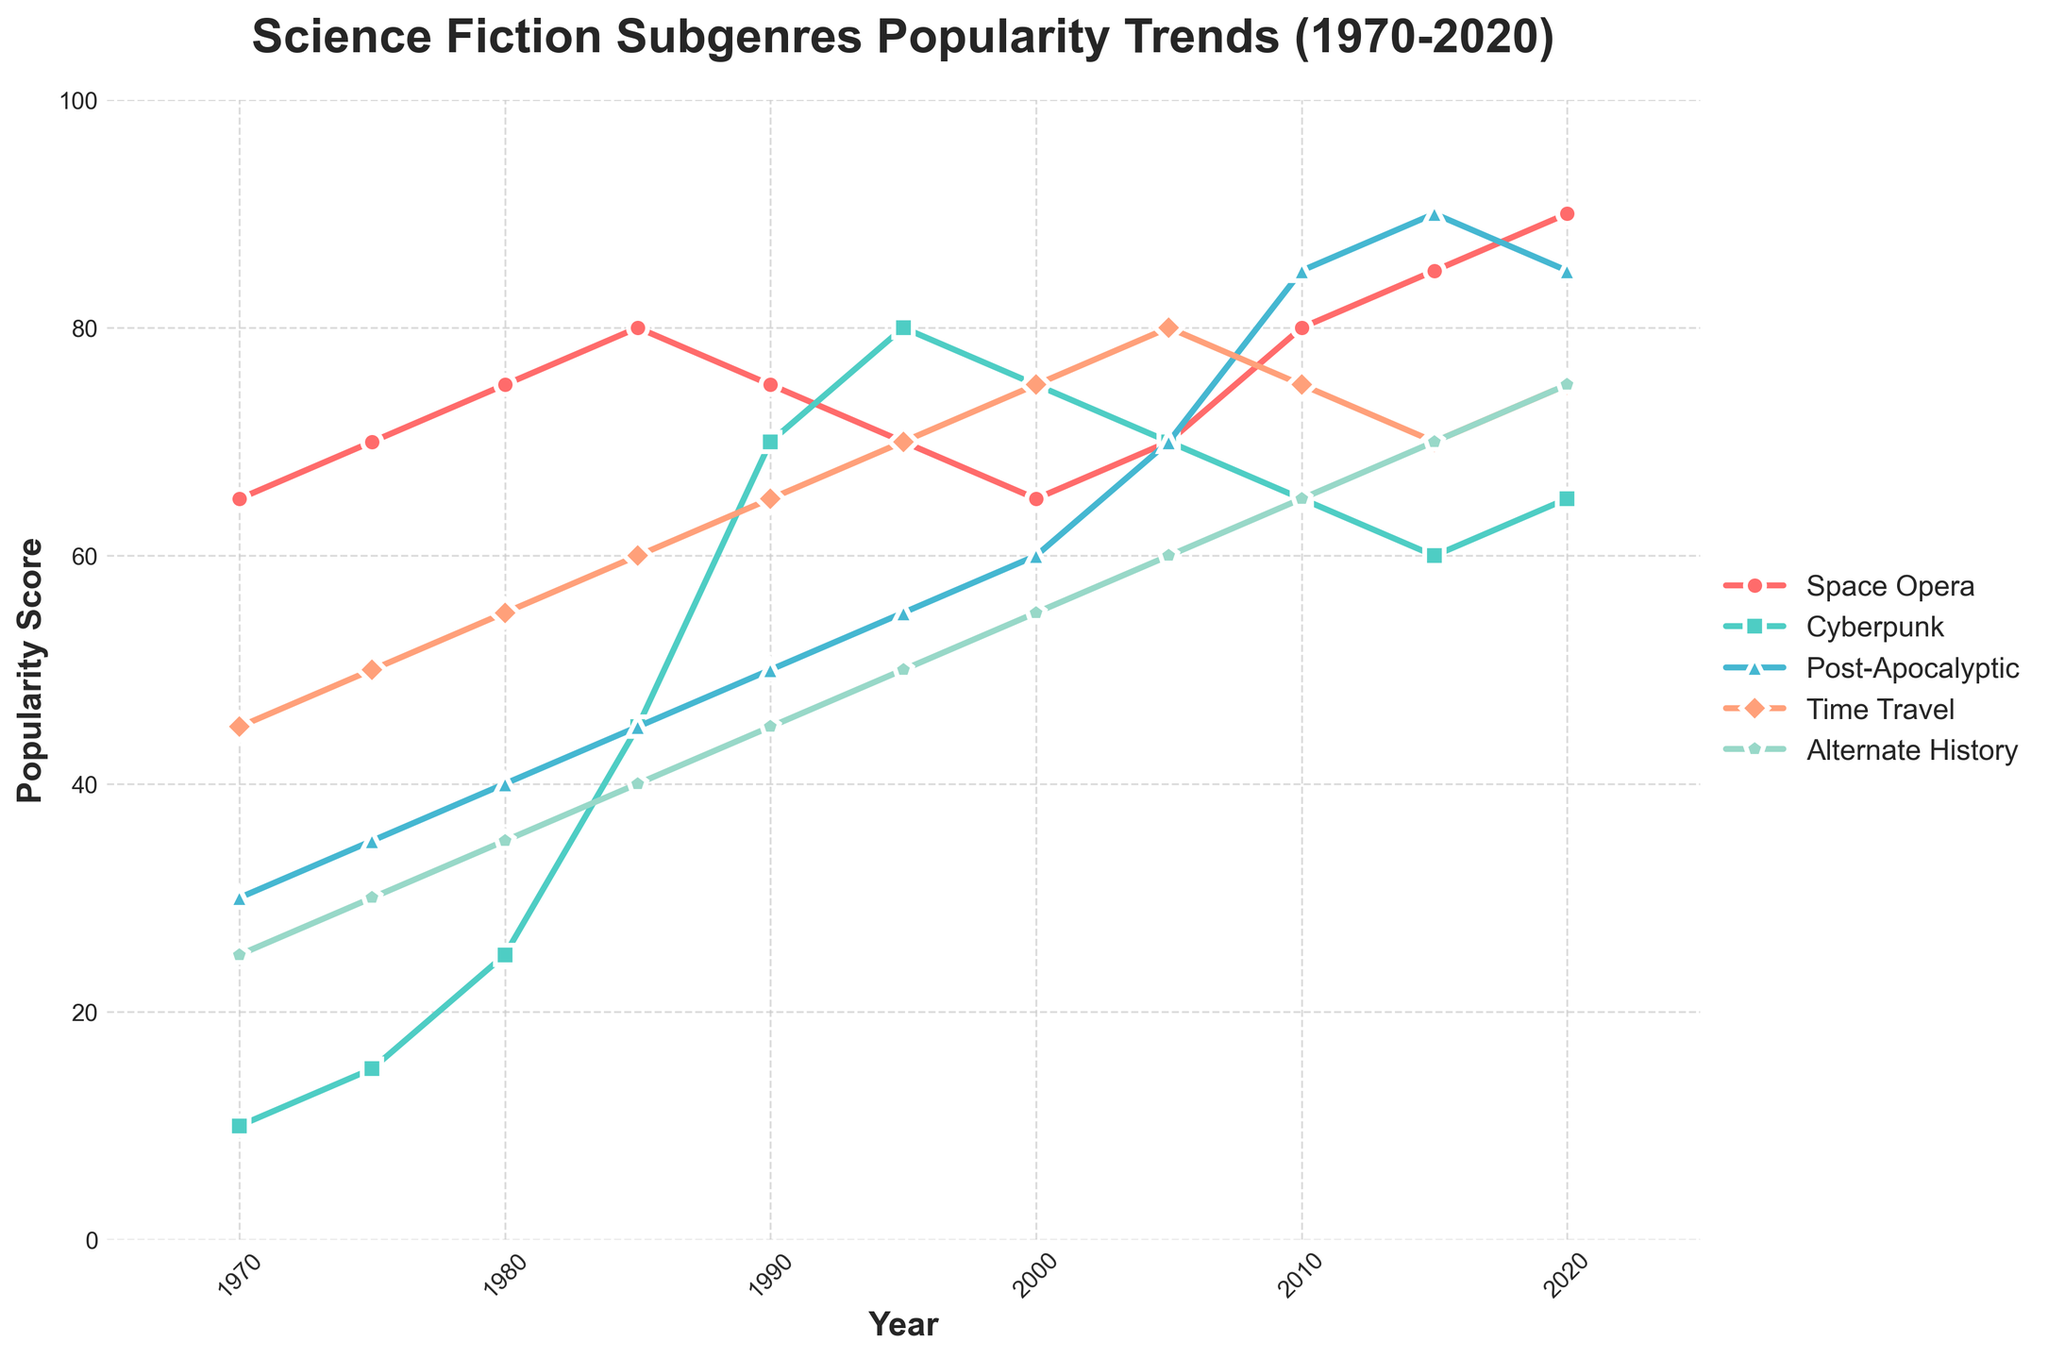What is the trend of the Space Opera subgenre from 1970 to 2020? The Space Opera subgenre starts at a popularity score of 65 in 1970 and shows an upward trend, reaching its peak at 90 in 2020.
Answer: Upward trend Which subgenre experienced the highest increase in popularity from 1970 to 2020? By examining the start and end values of each subgenre, the Post-Apocalyptic subgenre increased from 30 to 85, reflecting the highest increase of 55 points.
Answer: Post-Apocalyptic In which year did Cyberpunk reach its peak popularity? The Cyberpunk subgenre achieved its peak popularity in 1995 with a score of 80.
Answer: 1995 Between which years did the Time Travel subgenre see the steepest rise in popularity? The Time Travel subgenre saw multiple rises, but the steepest rise occurred between 1970 (popularity score of 45) and 2005 (popularity score of 80), a 35-point increase.
Answer: 1970-2005 How does the popularity of Alternate History in 2020 compare to its popularity in 1970? In 1970, Alternate History had a score of 25, which increased to 75 by 2020. This is a rise of 50 points over 50 years.
Answer: Higher in 2020 What is the average popularity score of Cyberpunk from 1970 to 2020? Sum the scores of Cyberpunk for each year (10 + 15 + 25 + 45 + 70 + 80 + 75 + 70 + 65 + 60 + 65 = 580) and divide by the number of years (11). The average score is 580 / 11 ≈ 52.7.
Answer: 52.7 Which subgenre had the least variation in popularity from 1970 to 2020? By visually examining the consistency in trends, Alternate History appears to have the least variation as it scales up at a steady pace compared to the others.
Answer: Alternate History What was the popularity score of Post-Apocalyptic subgenre in 2000, and how does it compare to its score in 2015? In 2000, the score was 60. In 2015, it was 90. The increase from 2000 to 2015 was 30 points.
Answer: Increased by 30 points Which subgenre showed a dip in popularity after reaching a peak, and in which years did this occur? Space Opera peaked in 1985 at 80 and then dipped to 75 in 1990, showing a decrease of 5 points.
Answer: Space Opera, 1985-1990 Arrange the subgenres in descending order of their popularity scores in 2020. The scores in 2020 are: Space Opera (90), Cyberpunk (65), Post-Apocalyptic (85), Time Travel (75), Alternate History (75). Thus, the order is: Space Opera, Post-Apocalyptic, Time Travel, Alternate History, Cyberpunk.
Answer: Space Opera, Post-Apocalyptic, Time Travel/Alternate History, Cyberpunk 